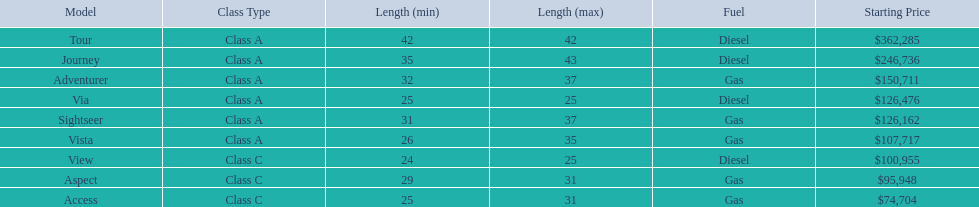Could you parse the entire table? {'header': ['Model', 'Class Type', 'Length (min)', 'Length (max)', 'Fuel', 'Starting Price'], 'rows': [['Tour', 'Class A', '42', '42', 'Diesel', '$362,285'], ['Journey', 'Class A', '35', '43', 'Diesel', '$246,736'], ['Adventurer', 'Class A', '32', '37', 'Gas', '$150,711'], ['Via', 'Class A', '25', '25', 'Diesel', '$126,476'], ['Sightseer', 'Class A', '31', '37', 'Gas', '$126,162'], ['Vista', 'Class A', '26', '35', 'Gas', '$107,717'], ['View', 'Class C', '24', '25', 'Diesel', '$100,955'], ['Aspect', 'Class C', '29', '31', 'Gas', '$95,948'], ['Access', 'Class C', '25', '31', 'Gas', '$74,704']]} What models are available from winnebago industries? Tour, Journey, Adventurer, Via, Sightseer, Vista, View, Aspect, Access. What are their starting prices? $362,285, $246,736, $150,711, $126,476, $126,162, $107,717, $100,955, $95,948, $74,704. Which model has the most costly starting price? Tour. 